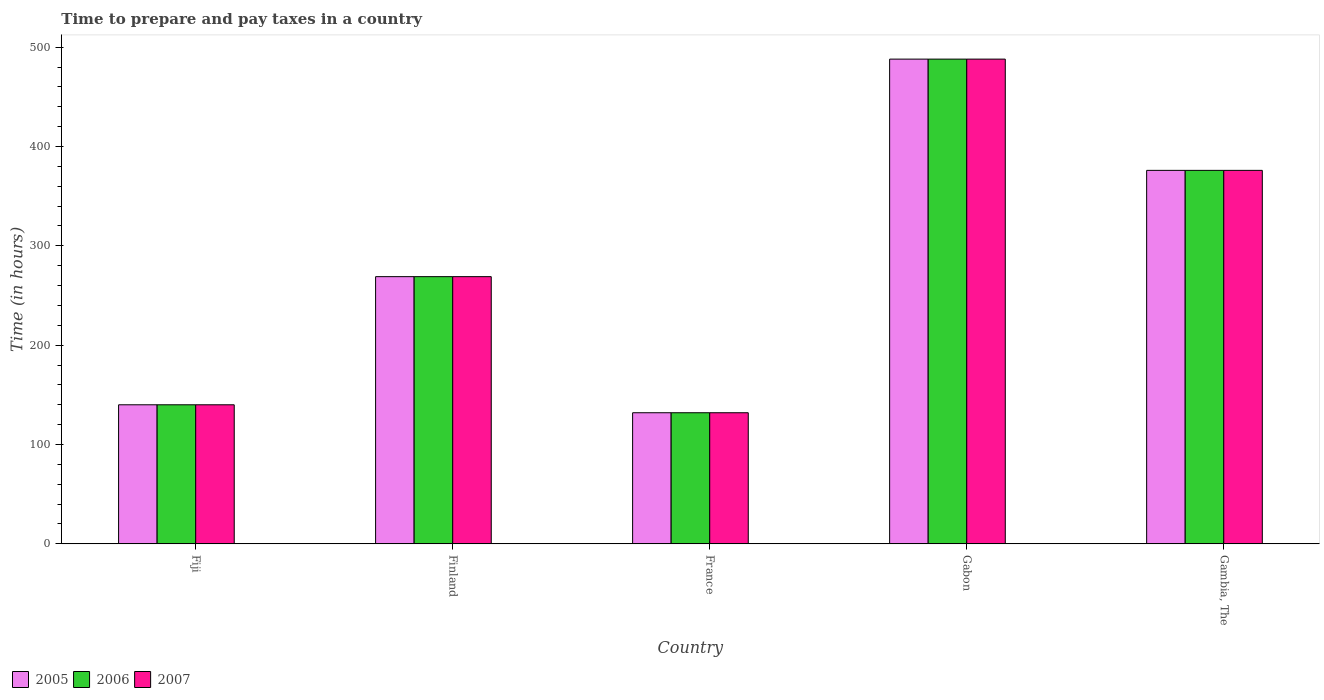How many groups of bars are there?
Your answer should be compact. 5. Are the number of bars per tick equal to the number of legend labels?
Offer a very short reply. Yes. How many bars are there on the 1st tick from the left?
Your answer should be very brief. 3. What is the label of the 2nd group of bars from the left?
Your response must be concise. Finland. What is the number of hours required to prepare and pay taxes in 2007 in France?
Make the answer very short. 132. Across all countries, what is the maximum number of hours required to prepare and pay taxes in 2006?
Your answer should be compact. 488. Across all countries, what is the minimum number of hours required to prepare and pay taxes in 2006?
Offer a very short reply. 132. In which country was the number of hours required to prepare and pay taxes in 2007 maximum?
Keep it short and to the point. Gabon. In which country was the number of hours required to prepare and pay taxes in 2006 minimum?
Your answer should be very brief. France. What is the total number of hours required to prepare and pay taxes in 2005 in the graph?
Make the answer very short. 1405. What is the difference between the number of hours required to prepare and pay taxes in 2006 in Fiji and that in France?
Your answer should be very brief. 8. What is the difference between the number of hours required to prepare and pay taxes in 2007 in Fiji and the number of hours required to prepare and pay taxes in 2005 in Gambia, The?
Give a very brief answer. -236. What is the average number of hours required to prepare and pay taxes in 2005 per country?
Your response must be concise. 281. What is the difference between the number of hours required to prepare and pay taxes of/in 2005 and number of hours required to prepare and pay taxes of/in 2006 in Gambia, The?
Offer a very short reply. 0. In how many countries, is the number of hours required to prepare and pay taxes in 2005 greater than 40 hours?
Offer a terse response. 5. What is the ratio of the number of hours required to prepare and pay taxes in 2007 in Fiji to that in Gambia, The?
Provide a succinct answer. 0.37. Is the number of hours required to prepare and pay taxes in 2007 in Fiji less than that in France?
Give a very brief answer. No. What is the difference between the highest and the second highest number of hours required to prepare and pay taxes in 2006?
Ensure brevity in your answer.  112. What is the difference between the highest and the lowest number of hours required to prepare and pay taxes in 2006?
Provide a short and direct response. 356. In how many countries, is the number of hours required to prepare and pay taxes in 2005 greater than the average number of hours required to prepare and pay taxes in 2005 taken over all countries?
Provide a short and direct response. 2. Is the sum of the number of hours required to prepare and pay taxes in 2007 in Finland and Gambia, The greater than the maximum number of hours required to prepare and pay taxes in 2006 across all countries?
Your response must be concise. Yes. What does the 1st bar from the right in Gambia, The represents?
Give a very brief answer. 2007. How many bars are there?
Offer a very short reply. 15. How many countries are there in the graph?
Make the answer very short. 5. What is the difference between two consecutive major ticks on the Y-axis?
Offer a terse response. 100. What is the title of the graph?
Provide a short and direct response. Time to prepare and pay taxes in a country. What is the label or title of the X-axis?
Keep it short and to the point. Country. What is the label or title of the Y-axis?
Ensure brevity in your answer.  Time (in hours). What is the Time (in hours) in 2005 in Fiji?
Offer a terse response. 140. What is the Time (in hours) of 2006 in Fiji?
Your answer should be very brief. 140. What is the Time (in hours) in 2007 in Fiji?
Keep it short and to the point. 140. What is the Time (in hours) of 2005 in Finland?
Offer a very short reply. 269. What is the Time (in hours) of 2006 in Finland?
Your answer should be very brief. 269. What is the Time (in hours) of 2007 in Finland?
Give a very brief answer. 269. What is the Time (in hours) in 2005 in France?
Offer a very short reply. 132. What is the Time (in hours) of 2006 in France?
Keep it short and to the point. 132. What is the Time (in hours) in 2007 in France?
Offer a very short reply. 132. What is the Time (in hours) in 2005 in Gabon?
Ensure brevity in your answer.  488. What is the Time (in hours) of 2006 in Gabon?
Keep it short and to the point. 488. What is the Time (in hours) of 2007 in Gabon?
Give a very brief answer. 488. What is the Time (in hours) in 2005 in Gambia, The?
Your response must be concise. 376. What is the Time (in hours) in 2006 in Gambia, The?
Provide a short and direct response. 376. What is the Time (in hours) in 2007 in Gambia, The?
Your response must be concise. 376. Across all countries, what is the maximum Time (in hours) of 2005?
Keep it short and to the point. 488. Across all countries, what is the maximum Time (in hours) of 2006?
Offer a terse response. 488. Across all countries, what is the maximum Time (in hours) in 2007?
Your answer should be very brief. 488. Across all countries, what is the minimum Time (in hours) in 2005?
Make the answer very short. 132. Across all countries, what is the minimum Time (in hours) in 2006?
Provide a short and direct response. 132. Across all countries, what is the minimum Time (in hours) in 2007?
Your answer should be compact. 132. What is the total Time (in hours) in 2005 in the graph?
Give a very brief answer. 1405. What is the total Time (in hours) in 2006 in the graph?
Your answer should be very brief. 1405. What is the total Time (in hours) in 2007 in the graph?
Keep it short and to the point. 1405. What is the difference between the Time (in hours) of 2005 in Fiji and that in Finland?
Offer a terse response. -129. What is the difference between the Time (in hours) in 2006 in Fiji and that in Finland?
Offer a very short reply. -129. What is the difference between the Time (in hours) in 2007 in Fiji and that in Finland?
Your answer should be compact. -129. What is the difference between the Time (in hours) in 2005 in Fiji and that in France?
Make the answer very short. 8. What is the difference between the Time (in hours) of 2006 in Fiji and that in France?
Your answer should be very brief. 8. What is the difference between the Time (in hours) in 2005 in Fiji and that in Gabon?
Offer a terse response. -348. What is the difference between the Time (in hours) in 2006 in Fiji and that in Gabon?
Ensure brevity in your answer.  -348. What is the difference between the Time (in hours) in 2007 in Fiji and that in Gabon?
Offer a very short reply. -348. What is the difference between the Time (in hours) of 2005 in Fiji and that in Gambia, The?
Make the answer very short. -236. What is the difference between the Time (in hours) in 2006 in Fiji and that in Gambia, The?
Offer a very short reply. -236. What is the difference between the Time (in hours) in 2007 in Fiji and that in Gambia, The?
Your answer should be very brief. -236. What is the difference between the Time (in hours) of 2005 in Finland and that in France?
Your response must be concise. 137. What is the difference between the Time (in hours) in 2006 in Finland and that in France?
Your answer should be very brief. 137. What is the difference between the Time (in hours) of 2007 in Finland and that in France?
Provide a short and direct response. 137. What is the difference between the Time (in hours) of 2005 in Finland and that in Gabon?
Ensure brevity in your answer.  -219. What is the difference between the Time (in hours) in 2006 in Finland and that in Gabon?
Provide a succinct answer. -219. What is the difference between the Time (in hours) in 2007 in Finland and that in Gabon?
Your answer should be very brief. -219. What is the difference between the Time (in hours) in 2005 in Finland and that in Gambia, The?
Give a very brief answer. -107. What is the difference between the Time (in hours) of 2006 in Finland and that in Gambia, The?
Offer a very short reply. -107. What is the difference between the Time (in hours) of 2007 in Finland and that in Gambia, The?
Provide a short and direct response. -107. What is the difference between the Time (in hours) in 2005 in France and that in Gabon?
Your answer should be compact. -356. What is the difference between the Time (in hours) of 2006 in France and that in Gabon?
Ensure brevity in your answer.  -356. What is the difference between the Time (in hours) of 2007 in France and that in Gabon?
Keep it short and to the point. -356. What is the difference between the Time (in hours) in 2005 in France and that in Gambia, The?
Offer a very short reply. -244. What is the difference between the Time (in hours) of 2006 in France and that in Gambia, The?
Give a very brief answer. -244. What is the difference between the Time (in hours) of 2007 in France and that in Gambia, The?
Keep it short and to the point. -244. What is the difference between the Time (in hours) of 2005 in Gabon and that in Gambia, The?
Your answer should be very brief. 112. What is the difference between the Time (in hours) of 2006 in Gabon and that in Gambia, The?
Provide a short and direct response. 112. What is the difference between the Time (in hours) of 2007 in Gabon and that in Gambia, The?
Ensure brevity in your answer.  112. What is the difference between the Time (in hours) of 2005 in Fiji and the Time (in hours) of 2006 in Finland?
Make the answer very short. -129. What is the difference between the Time (in hours) of 2005 in Fiji and the Time (in hours) of 2007 in Finland?
Keep it short and to the point. -129. What is the difference between the Time (in hours) in 2006 in Fiji and the Time (in hours) in 2007 in Finland?
Your answer should be compact. -129. What is the difference between the Time (in hours) in 2006 in Fiji and the Time (in hours) in 2007 in France?
Your answer should be very brief. 8. What is the difference between the Time (in hours) in 2005 in Fiji and the Time (in hours) in 2006 in Gabon?
Ensure brevity in your answer.  -348. What is the difference between the Time (in hours) in 2005 in Fiji and the Time (in hours) in 2007 in Gabon?
Your answer should be very brief. -348. What is the difference between the Time (in hours) of 2006 in Fiji and the Time (in hours) of 2007 in Gabon?
Offer a very short reply. -348. What is the difference between the Time (in hours) in 2005 in Fiji and the Time (in hours) in 2006 in Gambia, The?
Provide a short and direct response. -236. What is the difference between the Time (in hours) of 2005 in Fiji and the Time (in hours) of 2007 in Gambia, The?
Your answer should be compact. -236. What is the difference between the Time (in hours) in 2006 in Fiji and the Time (in hours) in 2007 in Gambia, The?
Keep it short and to the point. -236. What is the difference between the Time (in hours) of 2005 in Finland and the Time (in hours) of 2006 in France?
Provide a short and direct response. 137. What is the difference between the Time (in hours) in 2005 in Finland and the Time (in hours) in 2007 in France?
Offer a terse response. 137. What is the difference between the Time (in hours) of 2006 in Finland and the Time (in hours) of 2007 in France?
Make the answer very short. 137. What is the difference between the Time (in hours) of 2005 in Finland and the Time (in hours) of 2006 in Gabon?
Keep it short and to the point. -219. What is the difference between the Time (in hours) of 2005 in Finland and the Time (in hours) of 2007 in Gabon?
Ensure brevity in your answer.  -219. What is the difference between the Time (in hours) in 2006 in Finland and the Time (in hours) in 2007 in Gabon?
Offer a very short reply. -219. What is the difference between the Time (in hours) in 2005 in Finland and the Time (in hours) in 2006 in Gambia, The?
Give a very brief answer. -107. What is the difference between the Time (in hours) in 2005 in Finland and the Time (in hours) in 2007 in Gambia, The?
Ensure brevity in your answer.  -107. What is the difference between the Time (in hours) of 2006 in Finland and the Time (in hours) of 2007 in Gambia, The?
Provide a short and direct response. -107. What is the difference between the Time (in hours) of 2005 in France and the Time (in hours) of 2006 in Gabon?
Your response must be concise. -356. What is the difference between the Time (in hours) of 2005 in France and the Time (in hours) of 2007 in Gabon?
Your response must be concise. -356. What is the difference between the Time (in hours) in 2006 in France and the Time (in hours) in 2007 in Gabon?
Make the answer very short. -356. What is the difference between the Time (in hours) of 2005 in France and the Time (in hours) of 2006 in Gambia, The?
Your answer should be very brief. -244. What is the difference between the Time (in hours) of 2005 in France and the Time (in hours) of 2007 in Gambia, The?
Keep it short and to the point. -244. What is the difference between the Time (in hours) in 2006 in France and the Time (in hours) in 2007 in Gambia, The?
Make the answer very short. -244. What is the difference between the Time (in hours) of 2005 in Gabon and the Time (in hours) of 2006 in Gambia, The?
Your response must be concise. 112. What is the difference between the Time (in hours) of 2005 in Gabon and the Time (in hours) of 2007 in Gambia, The?
Ensure brevity in your answer.  112. What is the difference between the Time (in hours) in 2006 in Gabon and the Time (in hours) in 2007 in Gambia, The?
Offer a very short reply. 112. What is the average Time (in hours) in 2005 per country?
Provide a short and direct response. 281. What is the average Time (in hours) of 2006 per country?
Ensure brevity in your answer.  281. What is the average Time (in hours) of 2007 per country?
Offer a terse response. 281. What is the difference between the Time (in hours) in 2005 and Time (in hours) in 2006 in Fiji?
Your answer should be very brief. 0. What is the difference between the Time (in hours) in 2006 and Time (in hours) in 2007 in Fiji?
Keep it short and to the point. 0. What is the difference between the Time (in hours) of 2005 and Time (in hours) of 2006 in Finland?
Make the answer very short. 0. What is the difference between the Time (in hours) in 2005 and Time (in hours) in 2007 in Finland?
Your answer should be compact. 0. What is the difference between the Time (in hours) of 2006 and Time (in hours) of 2007 in Finland?
Give a very brief answer. 0. What is the difference between the Time (in hours) of 2005 and Time (in hours) of 2006 in France?
Offer a very short reply. 0. What is the difference between the Time (in hours) of 2005 and Time (in hours) of 2007 in France?
Ensure brevity in your answer.  0. What is the difference between the Time (in hours) in 2006 and Time (in hours) in 2007 in Gabon?
Keep it short and to the point. 0. What is the difference between the Time (in hours) in 2005 and Time (in hours) in 2006 in Gambia, The?
Give a very brief answer. 0. What is the difference between the Time (in hours) in 2006 and Time (in hours) in 2007 in Gambia, The?
Provide a succinct answer. 0. What is the ratio of the Time (in hours) of 2005 in Fiji to that in Finland?
Provide a succinct answer. 0.52. What is the ratio of the Time (in hours) in 2006 in Fiji to that in Finland?
Your answer should be compact. 0.52. What is the ratio of the Time (in hours) of 2007 in Fiji to that in Finland?
Offer a very short reply. 0.52. What is the ratio of the Time (in hours) of 2005 in Fiji to that in France?
Offer a very short reply. 1.06. What is the ratio of the Time (in hours) of 2006 in Fiji to that in France?
Ensure brevity in your answer.  1.06. What is the ratio of the Time (in hours) in 2007 in Fiji to that in France?
Provide a succinct answer. 1.06. What is the ratio of the Time (in hours) of 2005 in Fiji to that in Gabon?
Your answer should be compact. 0.29. What is the ratio of the Time (in hours) in 2006 in Fiji to that in Gabon?
Provide a short and direct response. 0.29. What is the ratio of the Time (in hours) of 2007 in Fiji to that in Gabon?
Offer a very short reply. 0.29. What is the ratio of the Time (in hours) in 2005 in Fiji to that in Gambia, The?
Provide a short and direct response. 0.37. What is the ratio of the Time (in hours) of 2006 in Fiji to that in Gambia, The?
Your answer should be very brief. 0.37. What is the ratio of the Time (in hours) in 2007 in Fiji to that in Gambia, The?
Ensure brevity in your answer.  0.37. What is the ratio of the Time (in hours) in 2005 in Finland to that in France?
Give a very brief answer. 2.04. What is the ratio of the Time (in hours) in 2006 in Finland to that in France?
Make the answer very short. 2.04. What is the ratio of the Time (in hours) of 2007 in Finland to that in France?
Give a very brief answer. 2.04. What is the ratio of the Time (in hours) in 2005 in Finland to that in Gabon?
Offer a very short reply. 0.55. What is the ratio of the Time (in hours) in 2006 in Finland to that in Gabon?
Your answer should be very brief. 0.55. What is the ratio of the Time (in hours) in 2007 in Finland to that in Gabon?
Give a very brief answer. 0.55. What is the ratio of the Time (in hours) in 2005 in Finland to that in Gambia, The?
Give a very brief answer. 0.72. What is the ratio of the Time (in hours) in 2006 in Finland to that in Gambia, The?
Give a very brief answer. 0.72. What is the ratio of the Time (in hours) in 2007 in Finland to that in Gambia, The?
Provide a succinct answer. 0.72. What is the ratio of the Time (in hours) of 2005 in France to that in Gabon?
Offer a very short reply. 0.27. What is the ratio of the Time (in hours) in 2006 in France to that in Gabon?
Your response must be concise. 0.27. What is the ratio of the Time (in hours) in 2007 in France to that in Gabon?
Your response must be concise. 0.27. What is the ratio of the Time (in hours) in 2005 in France to that in Gambia, The?
Ensure brevity in your answer.  0.35. What is the ratio of the Time (in hours) in 2006 in France to that in Gambia, The?
Give a very brief answer. 0.35. What is the ratio of the Time (in hours) in 2007 in France to that in Gambia, The?
Your answer should be compact. 0.35. What is the ratio of the Time (in hours) of 2005 in Gabon to that in Gambia, The?
Offer a terse response. 1.3. What is the ratio of the Time (in hours) in 2006 in Gabon to that in Gambia, The?
Provide a succinct answer. 1.3. What is the ratio of the Time (in hours) in 2007 in Gabon to that in Gambia, The?
Keep it short and to the point. 1.3. What is the difference between the highest and the second highest Time (in hours) in 2005?
Offer a very short reply. 112. What is the difference between the highest and the second highest Time (in hours) in 2006?
Your answer should be very brief. 112. What is the difference between the highest and the second highest Time (in hours) of 2007?
Offer a very short reply. 112. What is the difference between the highest and the lowest Time (in hours) of 2005?
Your answer should be compact. 356. What is the difference between the highest and the lowest Time (in hours) of 2006?
Provide a short and direct response. 356. What is the difference between the highest and the lowest Time (in hours) in 2007?
Provide a short and direct response. 356. 